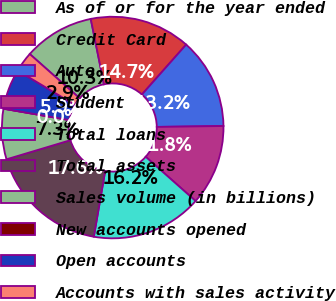Convert chart. <chart><loc_0><loc_0><loc_500><loc_500><pie_chart><fcel>As of or for the year ended<fcel>Credit Card<fcel>Auto<fcel>Student<fcel>Total loans<fcel>Total assets<fcel>Sales volume (in billions)<fcel>New accounts opened<fcel>Open accounts<fcel>Accounts with sales activity<nl><fcel>10.29%<fcel>14.71%<fcel>13.24%<fcel>11.76%<fcel>16.18%<fcel>17.65%<fcel>7.35%<fcel>0.0%<fcel>5.88%<fcel>2.94%<nl></chart> 